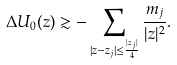<formula> <loc_0><loc_0><loc_500><loc_500>\Delta U _ { 0 } ( z ) \gtrsim - \sum _ { | z - z _ { j } | \leq \frac { | z _ { j } | } { 4 } } \frac { m _ { j } } { | z | ^ { 2 } } .</formula> 